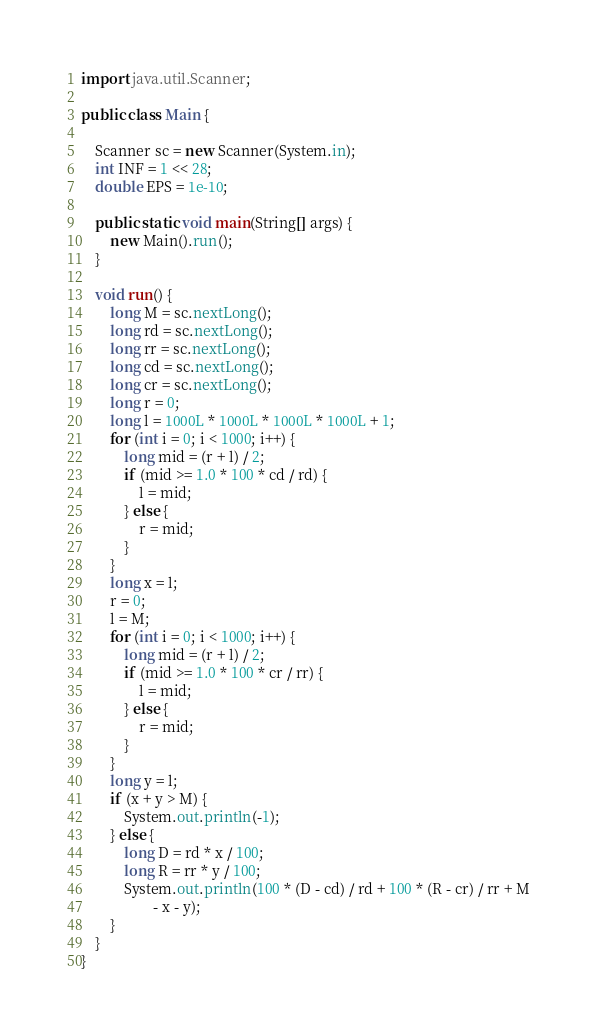Convert code to text. <code><loc_0><loc_0><loc_500><loc_500><_Java_>import java.util.Scanner;

public class Main {

	Scanner sc = new Scanner(System.in);
	int INF = 1 << 28;
	double EPS = 1e-10;

	public static void main(String[] args) {
		new Main().run();
	}

	void run() {
		long M = sc.nextLong();
		long rd = sc.nextLong();
		long rr = sc.nextLong();
		long cd = sc.nextLong();
		long cr = sc.nextLong();
		long r = 0;
		long l = 1000L * 1000L * 1000L * 1000L + 1;
		for (int i = 0; i < 1000; i++) {
			long mid = (r + l) / 2;
			if (mid >= 1.0 * 100 * cd / rd) {
				l = mid;
			} else {
				r = mid;
			}
		}
		long x = l;
		r = 0;
		l = M;
		for (int i = 0; i < 1000; i++) {
			long mid = (r + l) / 2;
			if (mid >= 1.0 * 100 * cr / rr) {
				l = mid;
			} else {
				r = mid;
			}
		}
		long y = l;
		if (x + y > M) {
			System.out.println(-1);
		} else {
			long D = rd * x / 100;
			long R = rr * y / 100;
			System.out.println(100 * (D - cd) / rd + 100 * (R - cr) / rr + M
					- x - y);
		}
	}
}</code> 